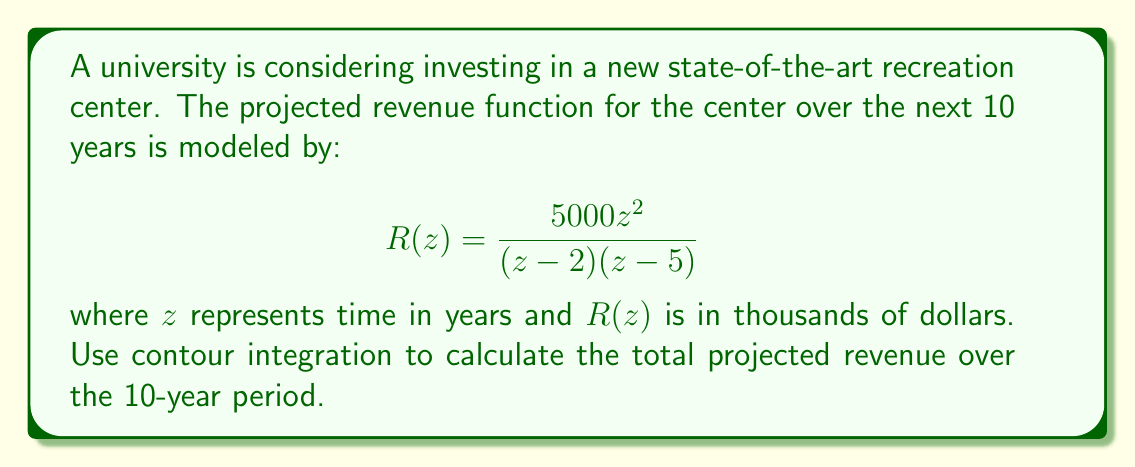Show me your answer to this math problem. To solve this problem, we'll use the residue theorem from complex analysis. The steps are as follows:

1) The total revenue over 10 years is equivalent to the integral of $R(z)$ from 0 to 10.

2) We can evaluate this using a semicircular contour in the upper half-plane, with radius 10 centered at the origin.

3) The residue theorem states:

   $$\oint_C f(z)dz = 2\pi i \sum_{k=1}^n \text{Res}(f, a_k)$$

   where $a_k$ are the poles inside the contour.

4) In our case, there are two poles: at $z=2$ and $z=5$. Both are within our contour.

5) Let's calculate the residues:

   At $z=2$:
   $$\text{Res}(R,2) = \lim_{z \to 2} (z-2)R(z) = \lim_{z \to 2} \frac{5000z^2}{z-5} = \frac{20000}{-3} = -6666.67$$

   At $z=5$:
   $$\text{Res}(R,5) = \lim_{z \to 5} (z-5)R(z) = \lim_{z \to 5} \frac{5000z^2}{z-2} = \frac{125000}{3} = 41666.67$$

6) Applying the residue theorem:

   $$\oint_C R(z)dz = 2\pi i (-6666.67 + 41666.67) = 2\pi i (35000)$$

7) The integral we want is half of this (due to the semicircular contour):

   $$\int_0^{10} R(z)dz = \pi i (35000)$$

8) Taking the real part (as revenue is real), we get:

   Total Revenue = $35000\pi$ thousand dollars = $109,955.74$ thousand dollars
Answer: $109,955,740 (or approximately $110 million) 